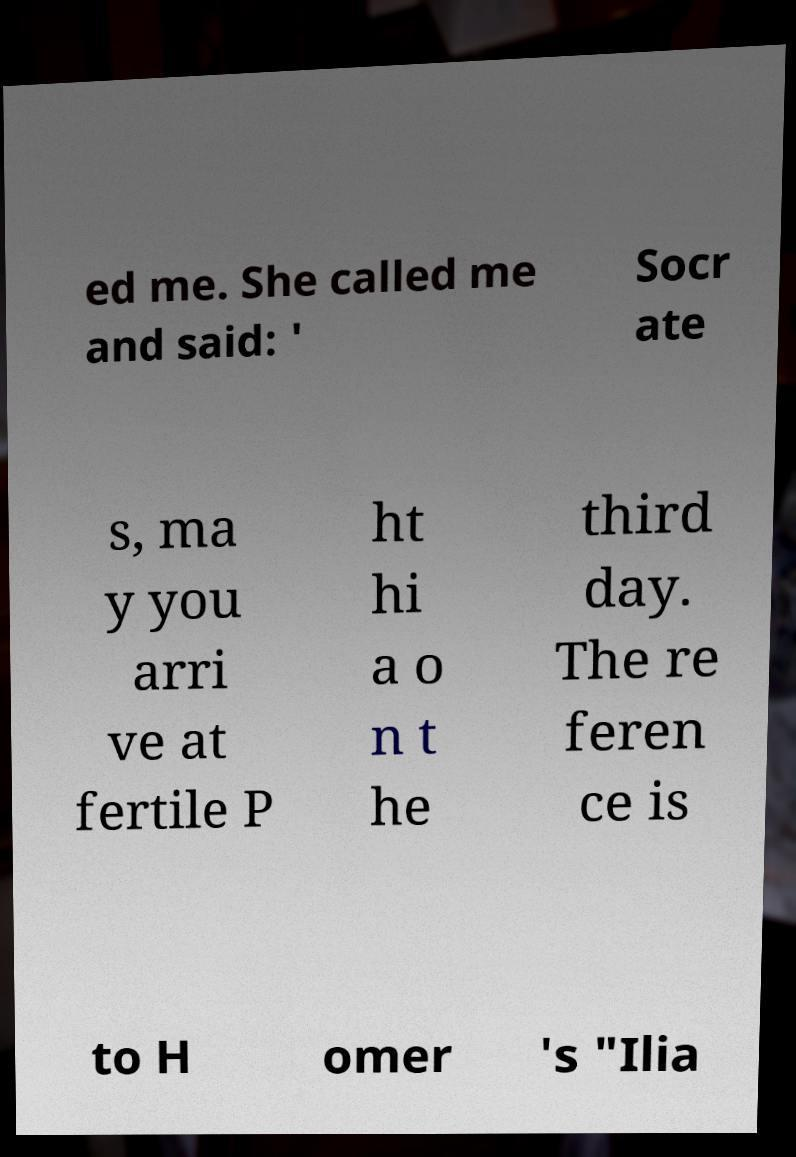Please identify and transcribe the text found in this image. ed me. She called me and said: ' Socr ate s, ma y you arri ve at fertile P ht hi a o n t he third day. The re feren ce is to H omer 's "Ilia 